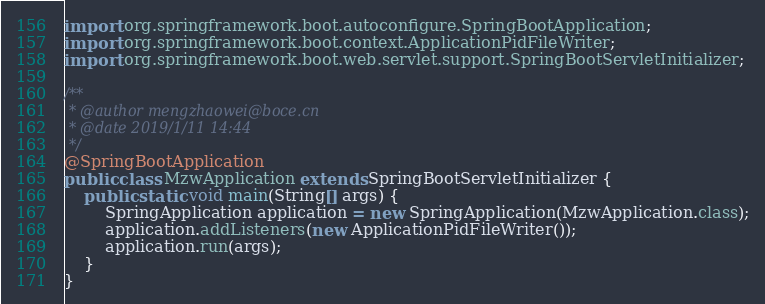<code> <loc_0><loc_0><loc_500><loc_500><_Java_>import org.springframework.boot.autoconfigure.SpringBootApplication;
import org.springframework.boot.context.ApplicationPidFileWriter;
import org.springframework.boot.web.servlet.support.SpringBootServletInitializer;

/**
 * @author mengzhaowei@boce.cn
 * @date 2019/1/11 14:44
 */
@SpringBootApplication
public class MzwApplication extends SpringBootServletInitializer {
    public static void main(String[] args) {
        SpringApplication application = new SpringApplication(MzwApplication.class);
        application.addListeners(new ApplicationPidFileWriter());
        application.run(args);
    }
}
</code> 